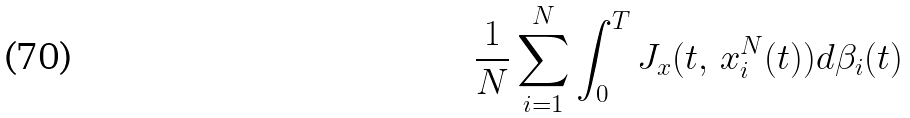<formula> <loc_0><loc_0><loc_500><loc_500>\frac { 1 } { N } \sum _ { i = 1 } ^ { N } \int _ { 0 } ^ { T } J _ { x } ( t , \, x _ { i } ^ { N } ( t ) ) d \beta _ { i } ( t )</formula> 